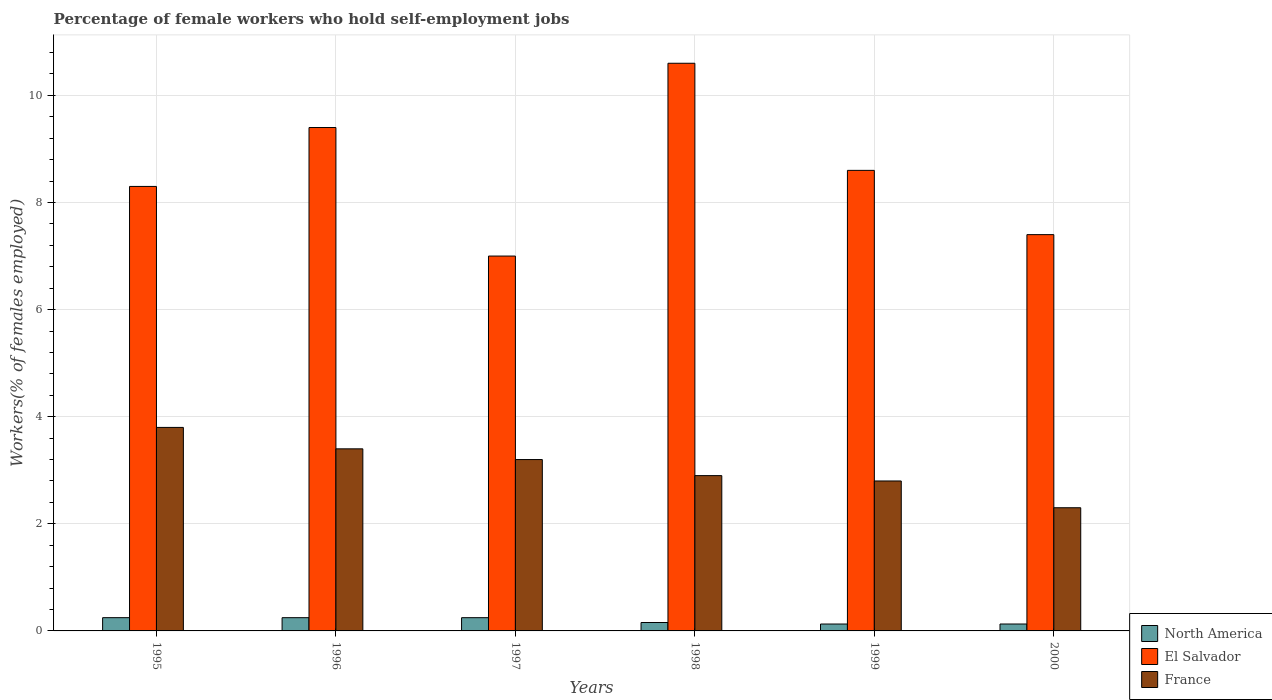How many groups of bars are there?
Ensure brevity in your answer.  6. Are the number of bars per tick equal to the number of legend labels?
Ensure brevity in your answer.  Yes. Are the number of bars on each tick of the X-axis equal?
Ensure brevity in your answer.  Yes. In how many cases, is the number of bars for a given year not equal to the number of legend labels?
Offer a very short reply. 0. What is the percentage of self-employed female workers in North America in 1999?
Offer a very short reply. 0.13. Across all years, what is the maximum percentage of self-employed female workers in North America?
Keep it short and to the point. 0.25. Across all years, what is the minimum percentage of self-employed female workers in France?
Your answer should be very brief. 2.3. In which year was the percentage of self-employed female workers in North America maximum?
Give a very brief answer. 1995. What is the total percentage of self-employed female workers in El Salvador in the graph?
Your answer should be very brief. 51.3. What is the difference between the percentage of self-employed female workers in El Salvador in 1995 and that in 2000?
Keep it short and to the point. 0.9. What is the difference between the percentage of self-employed female workers in France in 2000 and the percentage of self-employed female workers in North America in 1998?
Keep it short and to the point. 2.14. What is the average percentage of self-employed female workers in France per year?
Offer a terse response. 3.07. In the year 1998, what is the difference between the percentage of self-employed female workers in North America and percentage of self-employed female workers in El Salvador?
Ensure brevity in your answer.  -10.44. What is the ratio of the percentage of self-employed female workers in North America in 1995 to that in 1998?
Ensure brevity in your answer.  1.57. Is the percentage of self-employed female workers in North America in 1995 less than that in 1998?
Provide a succinct answer. No. Is the difference between the percentage of self-employed female workers in North America in 1997 and 2000 greater than the difference between the percentage of self-employed female workers in El Salvador in 1997 and 2000?
Provide a succinct answer. Yes. What is the difference between the highest and the second highest percentage of self-employed female workers in France?
Your answer should be compact. 0.4. What is the difference between the highest and the lowest percentage of self-employed female workers in El Salvador?
Your answer should be very brief. 3.6. How many bars are there?
Keep it short and to the point. 18. What is the difference between two consecutive major ticks on the Y-axis?
Keep it short and to the point. 2. Are the values on the major ticks of Y-axis written in scientific E-notation?
Your answer should be compact. No. What is the title of the graph?
Ensure brevity in your answer.  Percentage of female workers who hold self-employment jobs. Does "Senegal" appear as one of the legend labels in the graph?
Give a very brief answer. No. What is the label or title of the Y-axis?
Offer a very short reply. Workers(% of females employed). What is the Workers(% of females employed) in North America in 1995?
Your response must be concise. 0.25. What is the Workers(% of females employed) of El Salvador in 1995?
Provide a short and direct response. 8.3. What is the Workers(% of females employed) of France in 1995?
Offer a terse response. 3.8. What is the Workers(% of females employed) of North America in 1996?
Keep it short and to the point. 0.25. What is the Workers(% of females employed) of El Salvador in 1996?
Offer a very short reply. 9.4. What is the Workers(% of females employed) of France in 1996?
Provide a succinct answer. 3.4. What is the Workers(% of females employed) of North America in 1997?
Give a very brief answer. 0.25. What is the Workers(% of females employed) of France in 1997?
Give a very brief answer. 3.2. What is the Workers(% of females employed) of North America in 1998?
Keep it short and to the point. 0.16. What is the Workers(% of females employed) in El Salvador in 1998?
Provide a succinct answer. 10.6. What is the Workers(% of females employed) in France in 1998?
Your answer should be very brief. 2.9. What is the Workers(% of females employed) in North America in 1999?
Make the answer very short. 0.13. What is the Workers(% of females employed) in El Salvador in 1999?
Your answer should be very brief. 8.6. What is the Workers(% of females employed) in France in 1999?
Give a very brief answer. 2.8. What is the Workers(% of females employed) in North America in 2000?
Provide a succinct answer. 0.13. What is the Workers(% of females employed) of El Salvador in 2000?
Ensure brevity in your answer.  7.4. What is the Workers(% of females employed) in France in 2000?
Your response must be concise. 2.3. Across all years, what is the maximum Workers(% of females employed) in North America?
Provide a short and direct response. 0.25. Across all years, what is the maximum Workers(% of females employed) in El Salvador?
Your answer should be very brief. 10.6. Across all years, what is the maximum Workers(% of females employed) in France?
Offer a terse response. 3.8. Across all years, what is the minimum Workers(% of females employed) in North America?
Make the answer very short. 0.13. Across all years, what is the minimum Workers(% of females employed) of El Salvador?
Offer a terse response. 7. Across all years, what is the minimum Workers(% of females employed) of France?
Keep it short and to the point. 2.3. What is the total Workers(% of females employed) of North America in the graph?
Ensure brevity in your answer.  1.16. What is the total Workers(% of females employed) of El Salvador in the graph?
Your response must be concise. 51.3. What is the total Workers(% of females employed) in France in the graph?
Keep it short and to the point. 18.4. What is the difference between the Workers(% of females employed) of North America in 1995 and that in 1996?
Your answer should be very brief. 0. What is the difference between the Workers(% of females employed) of El Salvador in 1995 and that in 1996?
Make the answer very short. -1.1. What is the difference between the Workers(% of females employed) in North America in 1995 and that in 1997?
Provide a succinct answer. 0. What is the difference between the Workers(% of females employed) of El Salvador in 1995 and that in 1997?
Provide a succinct answer. 1.3. What is the difference between the Workers(% of females employed) in France in 1995 and that in 1997?
Your answer should be very brief. 0.6. What is the difference between the Workers(% of females employed) of North America in 1995 and that in 1998?
Offer a very short reply. 0.09. What is the difference between the Workers(% of females employed) in El Salvador in 1995 and that in 1998?
Your answer should be very brief. -2.3. What is the difference between the Workers(% of females employed) in France in 1995 and that in 1998?
Provide a short and direct response. 0.9. What is the difference between the Workers(% of females employed) of North America in 1995 and that in 1999?
Offer a terse response. 0.12. What is the difference between the Workers(% of females employed) in France in 1995 and that in 1999?
Provide a short and direct response. 1. What is the difference between the Workers(% of females employed) in North America in 1995 and that in 2000?
Offer a terse response. 0.12. What is the difference between the Workers(% of females employed) of France in 1995 and that in 2000?
Make the answer very short. 1.5. What is the difference between the Workers(% of females employed) in North America in 1996 and that in 1997?
Ensure brevity in your answer.  0. What is the difference between the Workers(% of females employed) in El Salvador in 1996 and that in 1997?
Your answer should be very brief. 2.4. What is the difference between the Workers(% of females employed) in France in 1996 and that in 1997?
Your response must be concise. 0.2. What is the difference between the Workers(% of females employed) in North America in 1996 and that in 1998?
Give a very brief answer. 0.09. What is the difference between the Workers(% of females employed) in North America in 1996 and that in 1999?
Your answer should be compact. 0.12. What is the difference between the Workers(% of females employed) of North America in 1996 and that in 2000?
Ensure brevity in your answer.  0.12. What is the difference between the Workers(% of females employed) of France in 1996 and that in 2000?
Keep it short and to the point. 1.1. What is the difference between the Workers(% of females employed) in North America in 1997 and that in 1998?
Provide a short and direct response. 0.09. What is the difference between the Workers(% of females employed) in France in 1997 and that in 1998?
Provide a succinct answer. 0.3. What is the difference between the Workers(% of females employed) in North America in 1997 and that in 1999?
Your response must be concise. 0.12. What is the difference between the Workers(% of females employed) in El Salvador in 1997 and that in 1999?
Your response must be concise. -1.6. What is the difference between the Workers(% of females employed) in North America in 1997 and that in 2000?
Make the answer very short. 0.12. What is the difference between the Workers(% of females employed) of France in 1997 and that in 2000?
Offer a terse response. 0.9. What is the difference between the Workers(% of females employed) of North America in 1998 and that in 1999?
Provide a short and direct response. 0.03. What is the difference between the Workers(% of females employed) of El Salvador in 1998 and that in 1999?
Make the answer very short. 2. What is the difference between the Workers(% of females employed) in North America in 1998 and that in 2000?
Your answer should be very brief. 0.03. What is the difference between the Workers(% of females employed) of France in 1998 and that in 2000?
Your answer should be compact. 0.6. What is the difference between the Workers(% of females employed) in North America in 1999 and that in 2000?
Provide a short and direct response. -0. What is the difference between the Workers(% of females employed) in El Salvador in 1999 and that in 2000?
Ensure brevity in your answer.  1.2. What is the difference between the Workers(% of females employed) of North America in 1995 and the Workers(% of females employed) of El Salvador in 1996?
Provide a short and direct response. -9.15. What is the difference between the Workers(% of females employed) in North America in 1995 and the Workers(% of females employed) in France in 1996?
Your answer should be compact. -3.15. What is the difference between the Workers(% of females employed) of El Salvador in 1995 and the Workers(% of females employed) of France in 1996?
Provide a short and direct response. 4.9. What is the difference between the Workers(% of females employed) of North America in 1995 and the Workers(% of females employed) of El Salvador in 1997?
Offer a very short reply. -6.75. What is the difference between the Workers(% of females employed) in North America in 1995 and the Workers(% of females employed) in France in 1997?
Provide a succinct answer. -2.95. What is the difference between the Workers(% of females employed) in North America in 1995 and the Workers(% of females employed) in El Salvador in 1998?
Offer a terse response. -10.35. What is the difference between the Workers(% of females employed) in North America in 1995 and the Workers(% of females employed) in France in 1998?
Make the answer very short. -2.65. What is the difference between the Workers(% of females employed) of El Salvador in 1995 and the Workers(% of females employed) of France in 1998?
Ensure brevity in your answer.  5.4. What is the difference between the Workers(% of females employed) of North America in 1995 and the Workers(% of females employed) of El Salvador in 1999?
Offer a terse response. -8.35. What is the difference between the Workers(% of females employed) of North America in 1995 and the Workers(% of females employed) of France in 1999?
Give a very brief answer. -2.55. What is the difference between the Workers(% of females employed) in El Salvador in 1995 and the Workers(% of females employed) in France in 1999?
Your answer should be compact. 5.5. What is the difference between the Workers(% of females employed) in North America in 1995 and the Workers(% of females employed) in El Salvador in 2000?
Make the answer very short. -7.15. What is the difference between the Workers(% of females employed) in North America in 1995 and the Workers(% of females employed) in France in 2000?
Provide a short and direct response. -2.05. What is the difference between the Workers(% of females employed) of El Salvador in 1995 and the Workers(% of females employed) of France in 2000?
Provide a short and direct response. 6. What is the difference between the Workers(% of females employed) of North America in 1996 and the Workers(% of females employed) of El Salvador in 1997?
Give a very brief answer. -6.75. What is the difference between the Workers(% of females employed) in North America in 1996 and the Workers(% of females employed) in France in 1997?
Keep it short and to the point. -2.95. What is the difference between the Workers(% of females employed) in El Salvador in 1996 and the Workers(% of females employed) in France in 1997?
Provide a short and direct response. 6.2. What is the difference between the Workers(% of females employed) of North America in 1996 and the Workers(% of females employed) of El Salvador in 1998?
Offer a terse response. -10.35. What is the difference between the Workers(% of females employed) of North America in 1996 and the Workers(% of females employed) of France in 1998?
Make the answer very short. -2.65. What is the difference between the Workers(% of females employed) in El Salvador in 1996 and the Workers(% of females employed) in France in 1998?
Provide a short and direct response. 6.5. What is the difference between the Workers(% of females employed) in North America in 1996 and the Workers(% of females employed) in El Salvador in 1999?
Provide a short and direct response. -8.35. What is the difference between the Workers(% of females employed) in North America in 1996 and the Workers(% of females employed) in France in 1999?
Give a very brief answer. -2.55. What is the difference between the Workers(% of females employed) in North America in 1996 and the Workers(% of females employed) in El Salvador in 2000?
Offer a very short reply. -7.15. What is the difference between the Workers(% of females employed) of North America in 1996 and the Workers(% of females employed) of France in 2000?
Ensure brevity in your answer.  -2.05. What is the difference between the Workers(% of females employed) in El Salvador in 1996 and the Workers(% of females employed) in France in 2000?
Keep it short and to the point. 7.1. What is the difference between the Workers(% of females employed) of North America in 1997 and the Workers(% of females employed) of El Salvador in 1998?
Your response must be concise. -10.35. What is the difference between the Workers(% of females employed) of North America in 1997 and the Workers(% of females employed) of France in 1998?
Your answer should be very brief. -2.65. What is the difference between the Workers(% of females employed) in North America in 1997 and the Workers(% of females employed) in El Salvador in 1999?
Provide a short and direct response. -8.35. What is the difference between the Workers(% of females employed) of North America in 1997 and the Workers(% of females employed) of France in 1999?
Make the answer very short. -2.55. What is the difference between the Workers(% of females employed) of El Salvador in 1997 and the Workers(% of females employed) of France in 1999?
Provide a short and direct response. 4.2. What is the difference between the Workers(% of females employed) of North America in 1997 and the Workers(% of females employed) of El Salvador in 2000?
Ensure brevity in your answer.  -7.15. What is the difference between the Workers(% of females employed) of North America in 1997 and the Workers(% of females employed) of France in 2000?
Offer a very short reply. -2.05. What is the difference between the Workers(% of females employed) of El Salvador in 1997 and the Workers(% of females employed) of France in 2000?
Offer a very short reply. 4.7. What is the difference between the Workers(% of females employed) of North America in 1998 and the Workers(% of females employed) of El Salvador in 1999?
Give a very brief answer. -8.44. What is the difference between the Workers(% of females employed) of North America in 1998 and the Workers(% of females employed) of France in 1999?
Offer a terse response. -2.64. What is the difference between the Workers(% of females employed) of North America in 1998 and the Workers(% of females employed) of El Salvador in 2000?
Offer a terse response. -7.24. What is the difference between the Workers(% of females employed) in North America in 1998 and the Workers(% of females employed) in France in 2000?
Offer a terse response. -2.14. What is the difference between the Workers(% of females employed) of El Salvador in 1998 and the Workers(% of females employed) of France in 2000?
Ensure brevity in your answer.  8.3. What is the difference between the Workers(% of females employed) in North America in 1999 and the Workers(% of females employed) in El Salvador in 2000?
Your answer should be very brief. -7.27. What is the difference between the Workers(% of females employed) of North America in 1999 and the Workers(% of females employed) of France in 2000?
Your answer should be compact. -2.17. What is the average Workers(% of females employed) of North America per year?
Offer a terse response. 0.19. What is the average Workers(% of females employed) in El Salvador per year?
Give a very brief answer. 8.55. What is the average Workers(% of females employed) of France per year?
Ensure brevity in your answer.  3.07. In the year 1995, what is the difference between the Workers(% of females employed) of North America and Workers(% of females employed) of El Salvador?
Your response must be concise. -8.05. In the year 1995, what is the difference between the Workers(% of females employed) of North America and Workers(% of females employed) of France?
Ensure brevity in your answer.  -3.55. In the year 1995, what is the difference between the Workers(% of females employed) of El Salvador and Workers(% of females employed) of France?
Keep it short and to the point. 4.5. In the year 1996, what is the difference between the Workers(% of females employed) in North America and Workers(% of females employed) in El Salvador?
Offer a terse response. -9.15. In the year 1996, what is the difference between the Workers(% of females employed) of North America and Workers(% of females employed) of France?
Offer a very short reply. -3.15. In the year 1997, what is the difference between the Workers(% of females employed) of North America and Workers(% of females employed) of El Salvador?
Make the answer very short. -6.75. In the year 1997, what is the difference between the Workers(% of females employed) in North America and Workers(% of females employed) in France?
Your response must be concise. -2.95. In the year 1998, what is the difference between the Workers(% of females employed) in North America and Workers(% of females employed) in El Salvador?
Offer a terse response. -10.44. In the year 1998, what is the difference between the Workers(% of females employed) in North America and Workers(% of females employed) in France?
Give a very brief answer. -2.74. In the year 1998, what is the difference between the Workers(% of females employed) of El Salvador and Workers(% of females employed) of France?
Offer a terse response. 7.7. In the year 1999, what is the difference between the Workers(% of females employed) of North America and Workers(% of females employed) of El Salvador?
Your answer should be compact. -8.47. In the year 1999, what is the difference between the Workers(% of females employed) of North America and Workers(% of females employed) of France?
Provide a succinct answer. -2.67. In the year 2000, what is the difference between the Workers(% of females employed) in North America and Workers(% of females employed) in El Salvador?
Provide a short and direct response. -7.27. In the year 2000, what is the difference between the Workers(% of females employed) in North America and Workers(% of females employed) in France?
Your response must be concise. -2.17. In the year 2000, what is the difference between the Workers(% of females employed) in El Salvador and Workers(% of females employed) in France?
Make the answer very short. 5.1. What is the ratio of the Workers(% of females employed) in El Salvador in 1995 to that in 1996?
Ensure brevity in your answer.  0.88. What is the ratio of the Workers(% of females employed) in France in 1995 to that in 1996?
Provide a succinct answer. 1.12. What is the ratio of the Workers(% of females employed) of North America in 1995 to that in 1997?
Your answer should be very brief. 1. What is the ratio of the Workers(% of females employed) of El Salvador in 1995 to that in 1997?
Your answer should be compact. 1.19. What is the ratio of the Workers(% of females employed) of France in 1995 to that in 1997?
Provide a short and direct response. 1.19. What is the ratio of the Workers(% of females employed) in North America in 1995 to that in 1998?
Offer a terse response. 1.57. What is the ratio of the Workers(% of females employed) of El Salvador in 1995 to that in 1998?
Give a very brief answer. 0.78. What is the ratio of the Workers(% of females employed) in France in 1995 to that in 1998?
Provide a succinct answer. 1.31. What is the ratio of the Workers(% of females employed) in North America in 1995 to that in 1999?
Give a very brief answer. 1.92. What is the ratio of the Workers(% of females employed) in El Salvador in 1995 to that in 1999?
Provide a succinct answer. 0.97. What is the ratio of the Workers(% of females employed) in France in 1995 to that in 1999?
Give a very brief answer. 1.36. What is the ratio of the Workers(% of females employed) in North America in 1995 to that in 2000?
Your response must be concise. 1.92. What is the ratio of the Workers(% of females employed) of El Salvador in 1995 to that in 2000?
Ensure brevity in your answer.  1.12. What is the ratio of the Workers(% of females employed) of France in 1995 to that in 2000?
Keep it short and to the point. 1.65. What is the ratio of the Workers(% of females employed) of North America in 1996 to that in 1997?
Give a very brief answer. 1. What is the ratio of the Workers(% of females employed) in El Salvador in 1996 to that in 1997?
Provide a short and direct response. 1.34. What is the ratio of the Workers(% of females employed) in North America in 1996 to that in 1998?
Your answer should be very brief. 1.57. What is the ratio of the Workers(% of females employed) in El Salvador in 1996 to that in 1998?
Give a very brief answer. 0.89. What is the ratio of the Workers(% of females employed) of France in 1996 to that in 1998?
Your answer should be compact. 1.17. What is the ratio of the Workers(% of females employed) in North America in 1996 to that in 1999?
Ensure brevity in your answer.  1.92. What is the ratio of the Workers(% of females employed) of El Salvador in 1996 to that in 1999?
Your answer should be very brief. 1.09. What is the ratio of the Workers(% of females employed) of France in 1996 to that in 1999?
Provide a succinct answer. 1.21. What is the ratio of the Workers(% of females employed) in North America in 1996 to that in 2000?
Your answer should be very brief. 1.91. What is the ratio of the Workers(% of females employed) in El Salvador in 1996 to that in 2000?
Your answer should be very brief. 1.27. What is the ratio of the Workers(% of females employed) of France in 1996 to that in 2000?
Offer a terse response. 1.48. What is the ratio of the Workers(% of females employed) of North America in 1997 to that in 1998?
Keep it short and to the point. 1.57. What is the ratio of the Workers(% of females employed) in El Salvador in 1997 to that in 1998?
Your answer should be very brief. 0.66. What is the ratio of the Workers(% of females employed) in France in 1997 to that in 1998?
Ensure brevity in your answer.  1.1. What is the ratio of the Workers(% of females employed) in North America in 1997 to that in 1999?
Provide a short and direct response. 1.92. What is the ratio of the Workers(% of females employed) in El Salvador in 1997 to that in 1999?
Your response must be concise. 0.81. What is the ratio of the Workers(% of females employed) of France in 1997 to that in 1999?
Make the answer very short. 1.14. What is the ratio of the Workers(% of females employed) in North America in 1997 to that in 2000?
Keep it short and to the point. 1.91. What is the ratio of the Workers(% of females employed) in El Salvador in 1997 to that in 2000?
Give a very brief answer. 0.95. What is the ratio of the Workers(% of females employed) in France in 1997 to that in 2000?
Ensure brevity in your answer.  1.39. What is the ratio of the Workers(% of females employed) in North America in 1998 to that in 1999?
Your answer should be compact. 1.22. What is the ratio of the Workers(% of females employed) in El Salvador in 1998 to that in 1999?
Your response must be concise. 1.23. What is the ratio of the Workers(% of females employed) in France in 1998 to that in 1999?
Provide a short and direct response. 1.04. What is the ratio of the Workers(% of females employed) of North America in 1998 to that in 2000?
Offer a terse response. 1.22. What is the ratio of the Workers(% of females employed) of El Salvador in 1998 to that in 2000?
Offer a very short reply. 1.43. What is the ratio of the Workers(% of females employed) of France in 1998 to that in 2000?
Provide a succinct answer. 1.26. What is the ratio of the Workers(% of females employed) of North America in 1999 to that in 2000?
Provide a succinct answer. 1. What is the ratio of the Workers(% of females employed) in El Salvador in 1999 to that in 2000?
Provide a succinct answer. 1.16. What is the ratio of the Workers(% of females employed) in France in 1999 to that in 2000?
Offer a terse response. 1.22. What is the difference between the highest and the second highest Workers(% of females employed) in El Salvador?
Make the answer very short. 1.2. What is the difference between the highest and the second highest Workers(% of females employed) in France?
Make the answer very short. 0.4. What is the difference between the highest and the lowest Workers(% of females employed) of North America?
Your answer should be very brief. 0.12. What is the difference between the highest and the lowest Workers(% of females employed) of France?
Your answer should be compact. 1.5. 